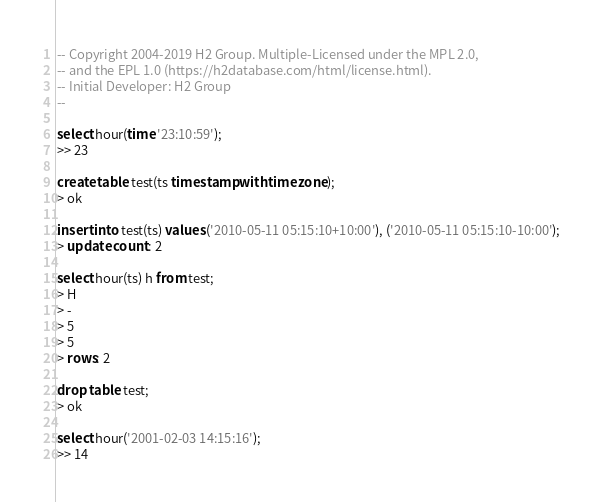Convert code to text. <code><loc_0><loc_0><loc_500><loc_500><_SQL_>-- Copyright 2004-2019 H2 Group. Multiple-Licensed under the MPL 2.0,
-- and the EPL 1.0 (https://h2database.com/html/license.html).
-- Initial Developer: H2 Group
--

select hour(time '23:10:59');
>> 23

create table test(ts timestamp with time zone);
> ok

insert into test(ts) values ('2010-05-11 05:15:10+10:00'), ('2010-05-11 05:15:10-10:00');
> update count: 2

select hour(ts) h from test;
> H
> -
> 5
> 5
> rows: 2

drop table test;
> ok

select hour('2001-02-03 14:15:16');
>> 14
</code> 